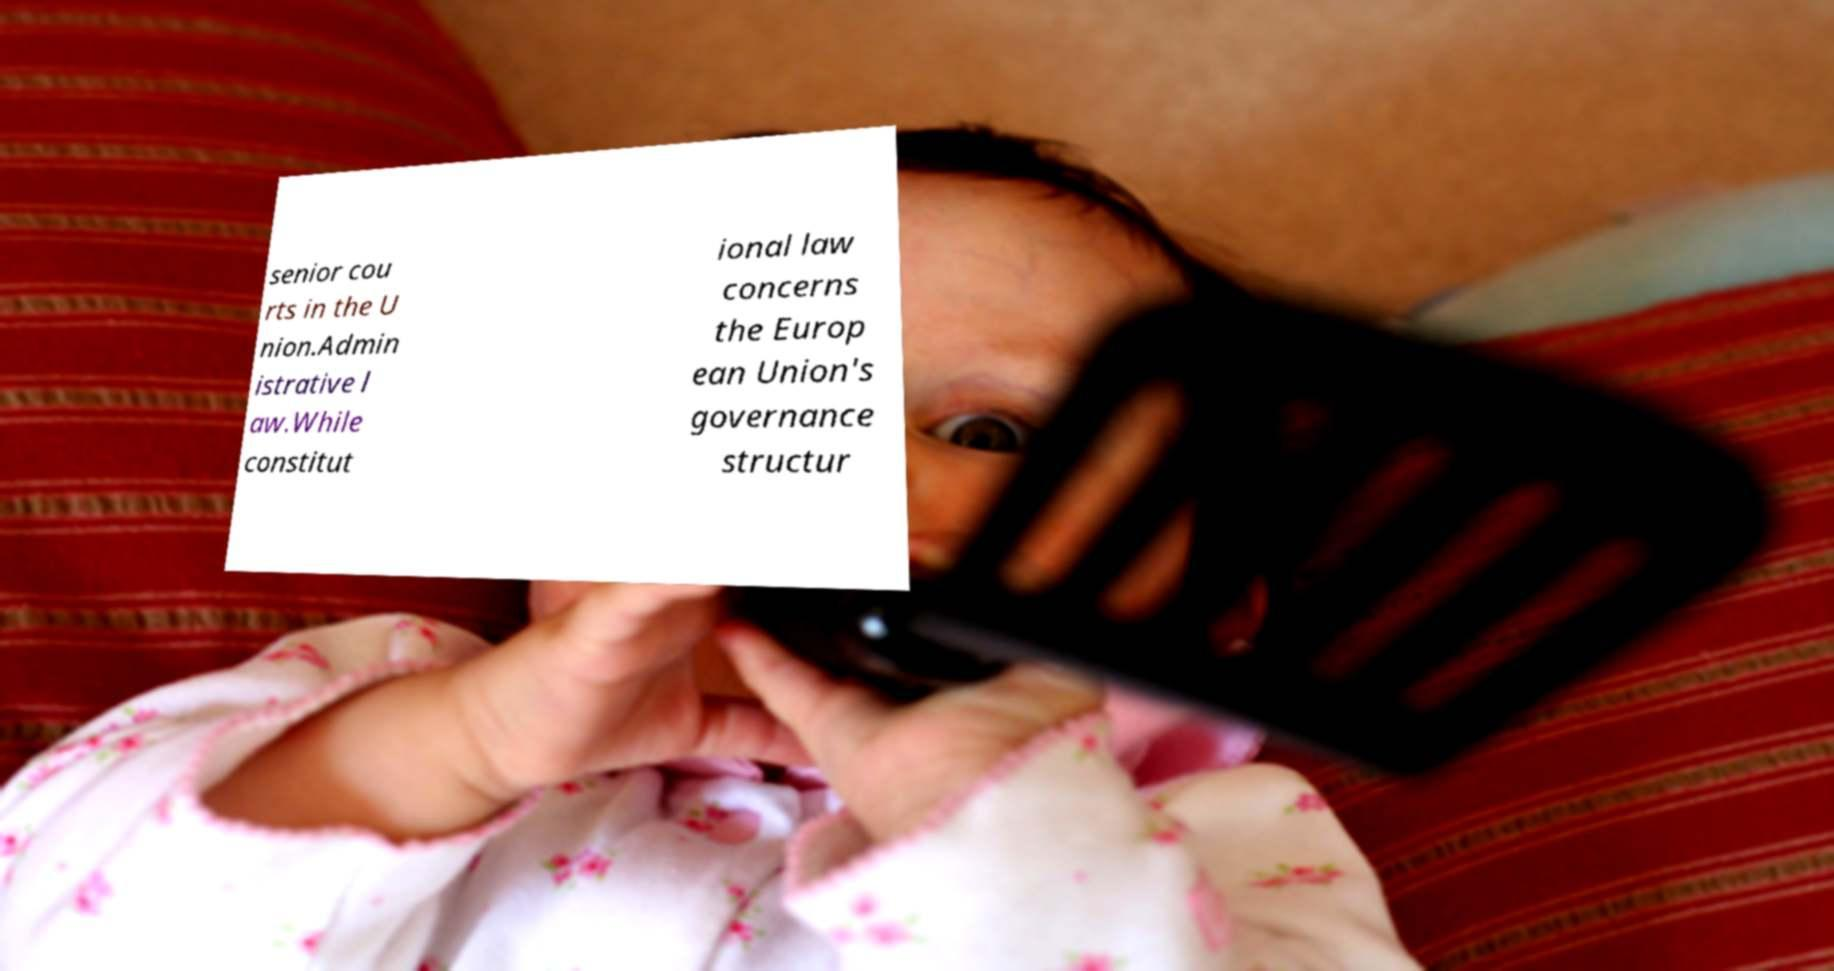Please identify and transcribe the text found in this image. senior cou rts in the U nion.Admin istrative l aw.While constitut ional law concerns the Europ ean Union's governance structur 